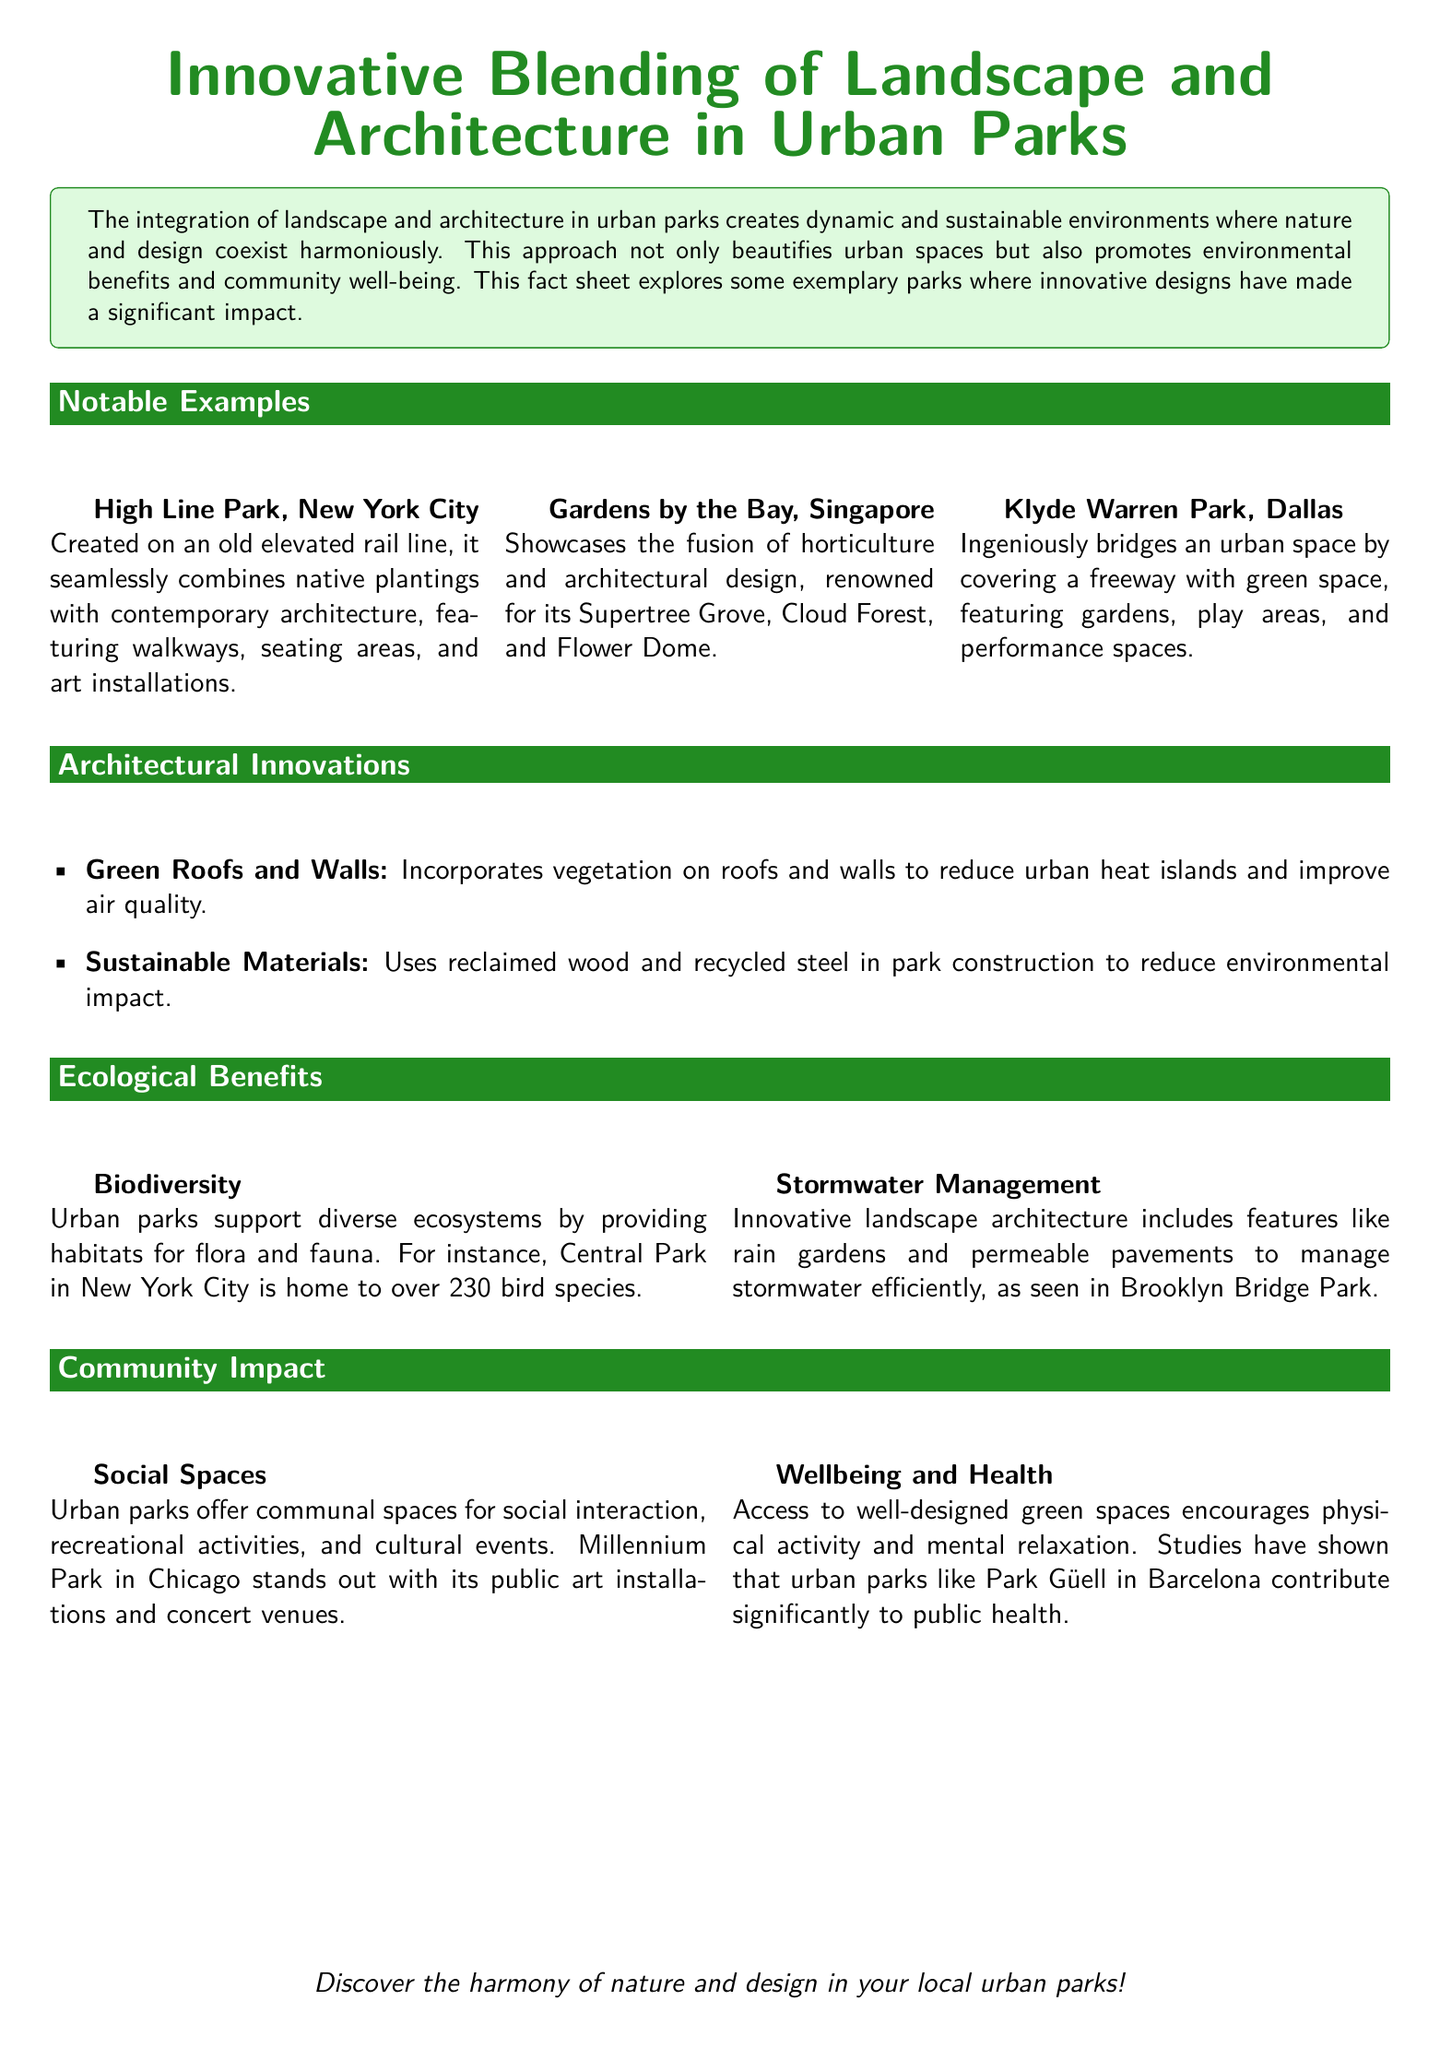what is the name of an urban park in New York City? The document mentions High Line Park and Central Park as notable urban parks in New York City.
Answer: High Line Park what innovative feature is found in Gardens by the Bay? The document highlights the Supertree Grove as a notable feature of Gardens by the Bay.
Answer: Supertree Grove how many bird species are supported in Central Park? The document states that Central Park is home to over 230 bird species.
Answer: 230 what type of materials are used in sustainable park construction? The document mentions the use of reclaimed wood and recycled steel in park construction.
Answer: Reclaimed wood and recycled steel what does Klyde Warren Park cover? The document explains that Klyde Warren Park ingeniously bridges an urban space by covering a freeway.
Answer: Freeway which city features Millennium Park? The document identifies Millennium Park as a notable urban park in Chicago.
Answer: Chicago what is one ecological benefit of urban parks? The document lists biodiversity and stormwater management as ecological benefits of urban parks.
Answer: Biodiversity which park is known for promoting public health significantly? The fact sheet mentions Park Güell in Barcelona as a park contributing significantly to public health.
Answer: Park Güell what are two architectural innovations mentioned in the document? The document lists green roofs and walls as well as sustainable materials as architectural innovations.
Answer: Green roofs, Sustainable materials 